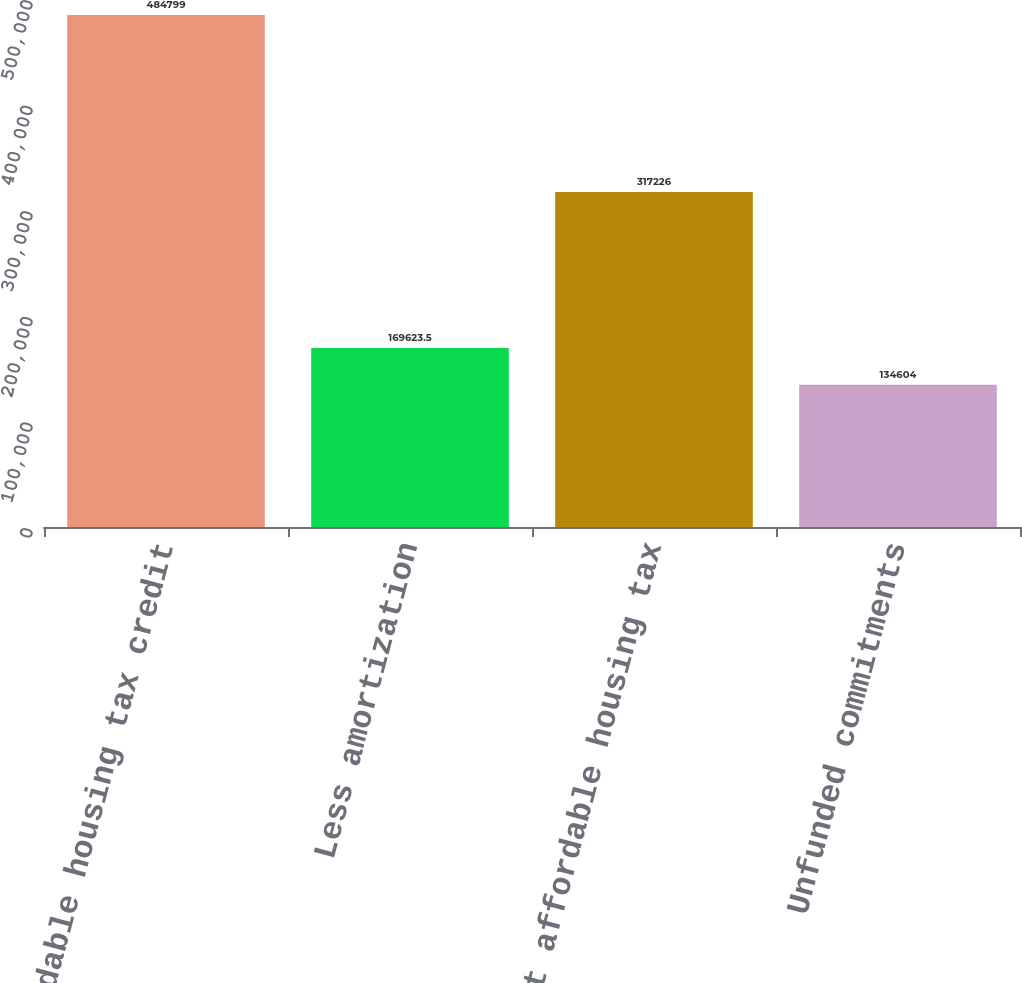<chart> <loc_0><loc_0><loc_500><loc_500><bar_chart><fcel>Affordable housing tax credit<fcel>Less amortization<fcel>Net affordable housing tax<fcel>Unfunded commitments<nl><fcel>484799<fcel>169624<fcel>317226<fcel>134604<nl></chart> 